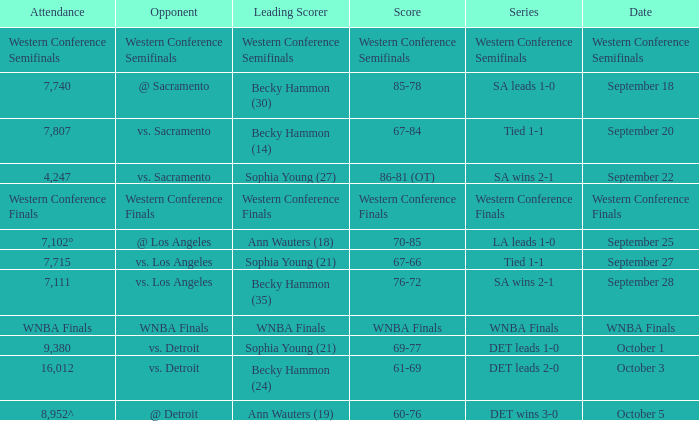Who is the leading scorer of the wnba finals series? WNBA Finals. Help me parse the entirety of this table. {'header': ['Attendance', 'Opponent', 'Leading Scorer', 'Score', 'Series', 'Date'], 'rows': [['Western Conference Semifinals', 'Western Conference Semifinals', 'Western Conference Semifinals', 'Western Conference Semifinals', 'Western Conference Semifinals', 'Western Conference Semifinals'], ['7,740', '@ Sacramento', 'Becky Hammon (30)', '85-78', 'SA leads 1-0', 'September 18'], ['7,807', 'vs. Sacramento', 'Becky Hammon (14)', '67-84', 'Tied 1-1', 'September 20'], ['4,247', 'vs. Sacramento', 'Sophia Young (27)', '86-81 (OT)', 'SA wins 2-1', 'September 22'], ['Western Conference Finals', 'Western Conference Finals', 'Western Conference Finals', 'Western Conference Finals', 'Western Conference Finals', 'Western Conference Finals'], ['7,102°', '@ Los Angeles', 'Ann Wauters (18)', '70-85', 'LA leads 1-0', 'September 25'], ['7,715', 'vs. Los Angeles', 'Sophia Young (21)', '67-66', 'Tied 1-1', 'September 27'], ['7,111', 'vs. Los Angeles', 'Becky Hammon (35)', '76-72', 'SA wins 2-1', 'September 28'], ['WNBA Finals', 'WNBA Finals', 'WNBA Finals', 'WNBA Finals', 'WNBA Finals', 'WNBA Finals'], ['9,380', 'vs. Detroit', 'Sophia Young (21)', '69-77', 'DET leads 1-0', 'October 1'], ['16,012', 'vs. Detroit', 'Becky Hammon (24)', '61-69', 'DET leads 2-0', 'October 3'], ['8,952^', '@ Detroit', 'Ann Wauters (19)', '60-76', 'DET wins 3-0', 'October 5']]} 